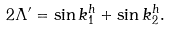<formula> <loc_0><loc_0><loc_500><loc_500>2 \Lambda ^ { \prime } = \sin k _ { 1 } ^ { h } + \sin k _ { 2 } ^ { h } .</formula> 